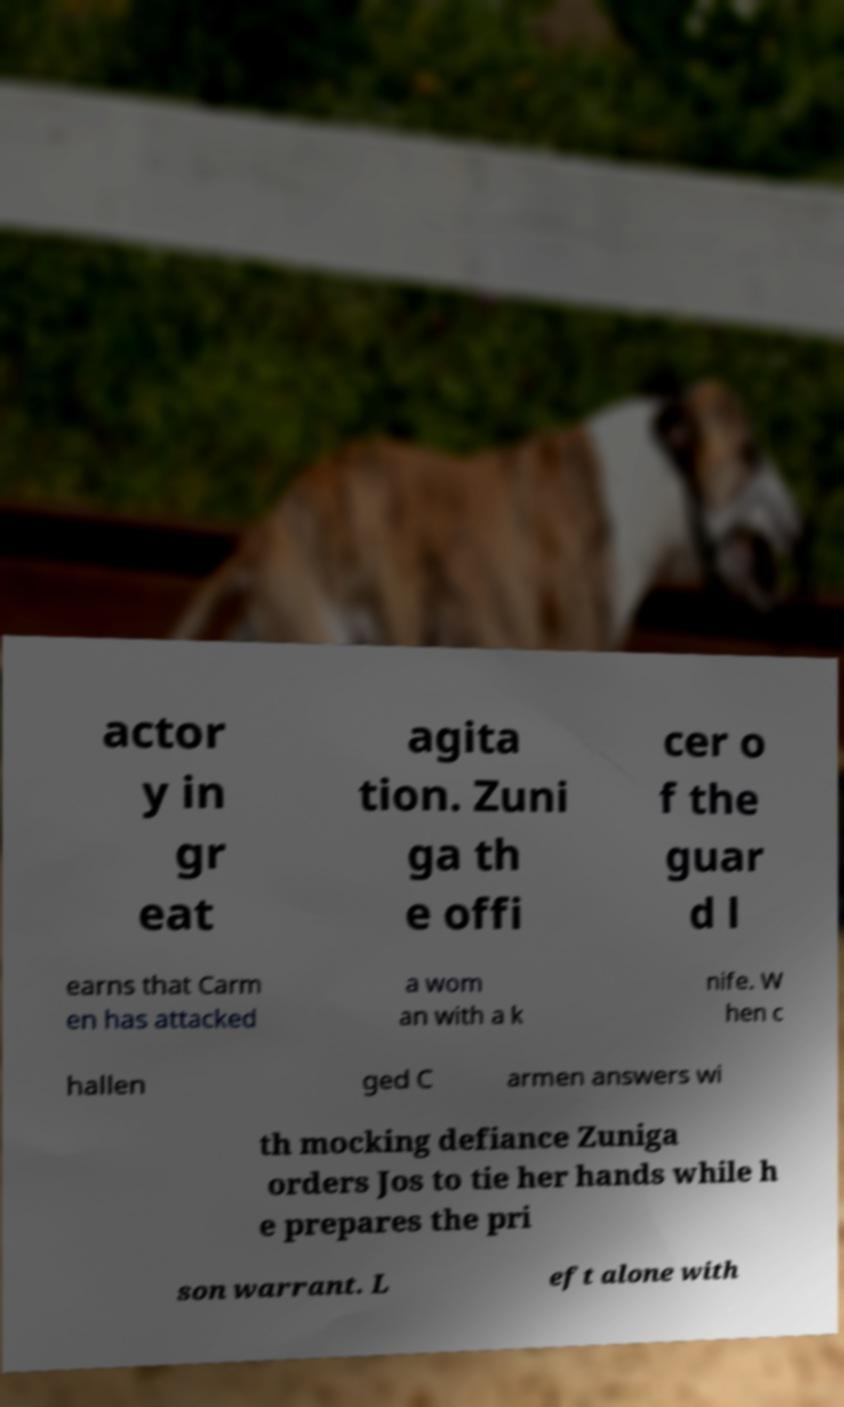For documentation purposes, I need the text within this image transcribed. Could you provide that? actor y in gr eat agita tion. Zuni ga th e offi cer o f the guar d l earns that Carm en has attacked a wom an with a k nife. W hen c hallen ged C armen answers wi th mocking defiance Zuniga orders Jos to tie her hands while h e prepares the pri son warrant. L eft alone with 